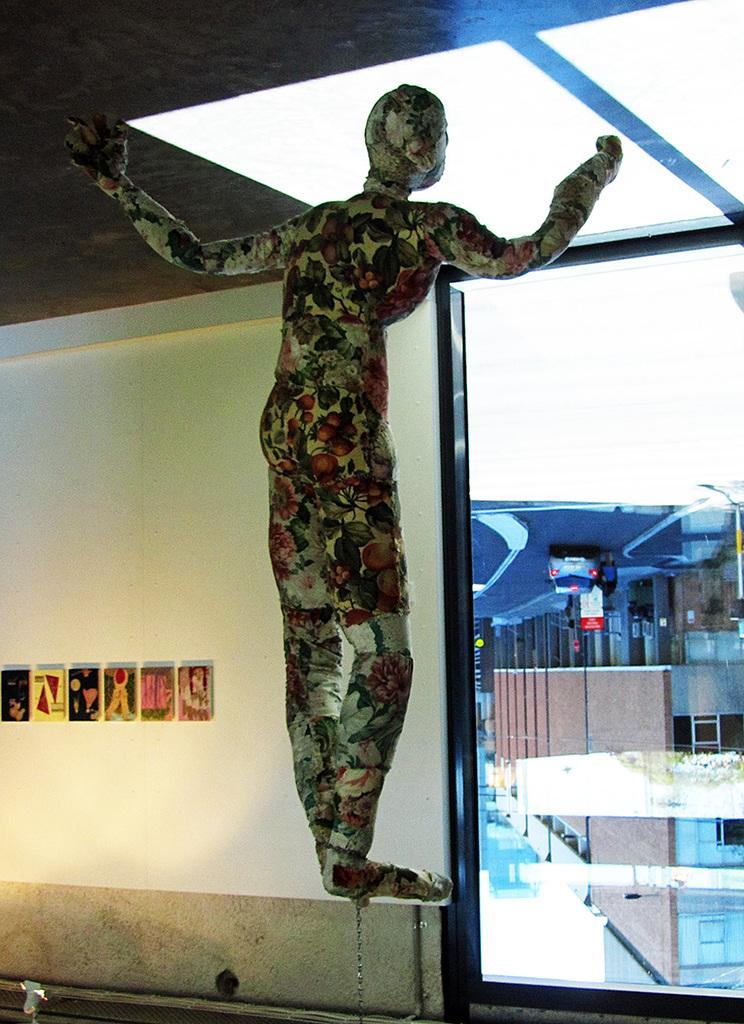What is the main subject of the image? The main subject of the image is a person's statue. How is the statue positioned in the image? The statue is kept on a chain. What can be seen in the background of the image? There are buildings visible in the background of the image. Is there any transportation visible in the image? Yes, there is a car parked on the road in the image. How many dimes are placed on the statue in the image? There are no dimes present on the statue in the image. What type of soap is used to clean the statue in the image? There is no soap or cleaning activity depicted in the image. 